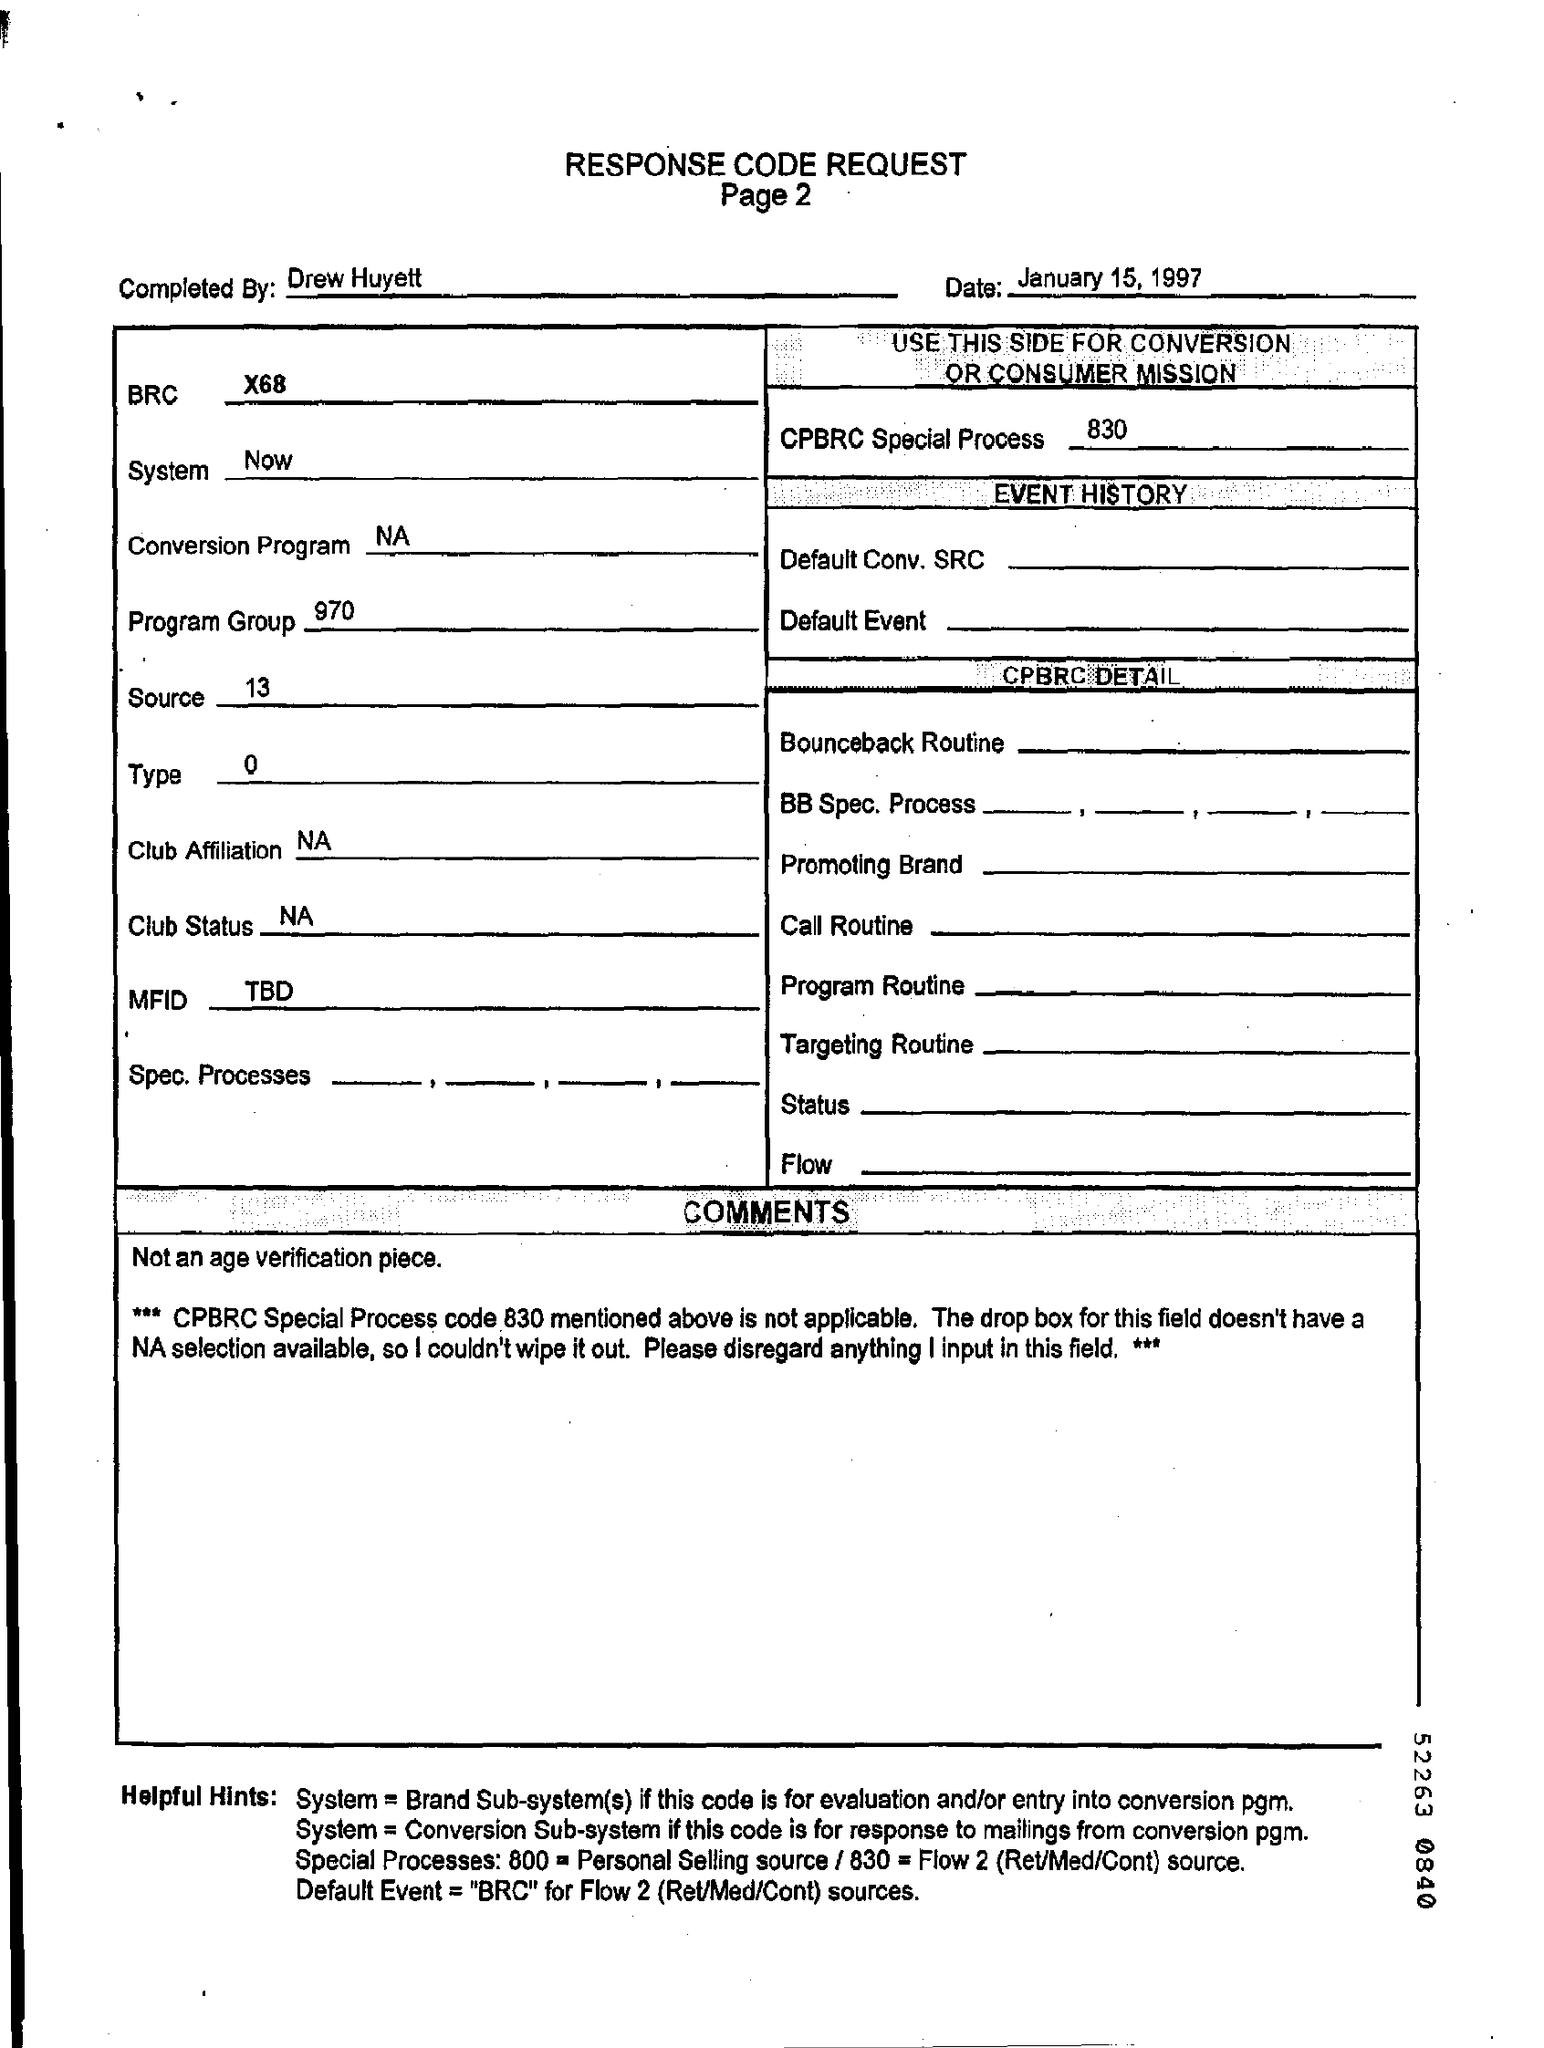By whom the response code request is completed ?
Offer a very short reply. Drew Huyett. What is the brc mentioned in the page ?
Your response must be concise. X68. What is the program group number mentioned in the given page ?
Give a very brief answer. 970. What is the source number mentioned in the page ?
Your answer should be compact. 13. 